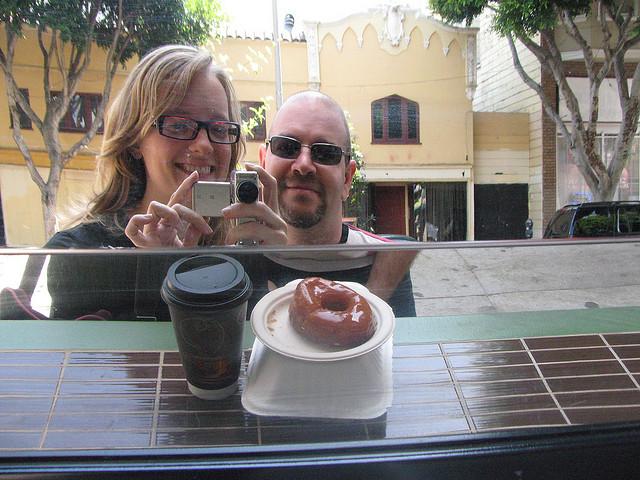How many doughnuts?
Give a very brief answer. 1. What is the lady holding?
Write a very short answer. Camera. Is the doughnut healthy to eat?
Quick response, please. No. 